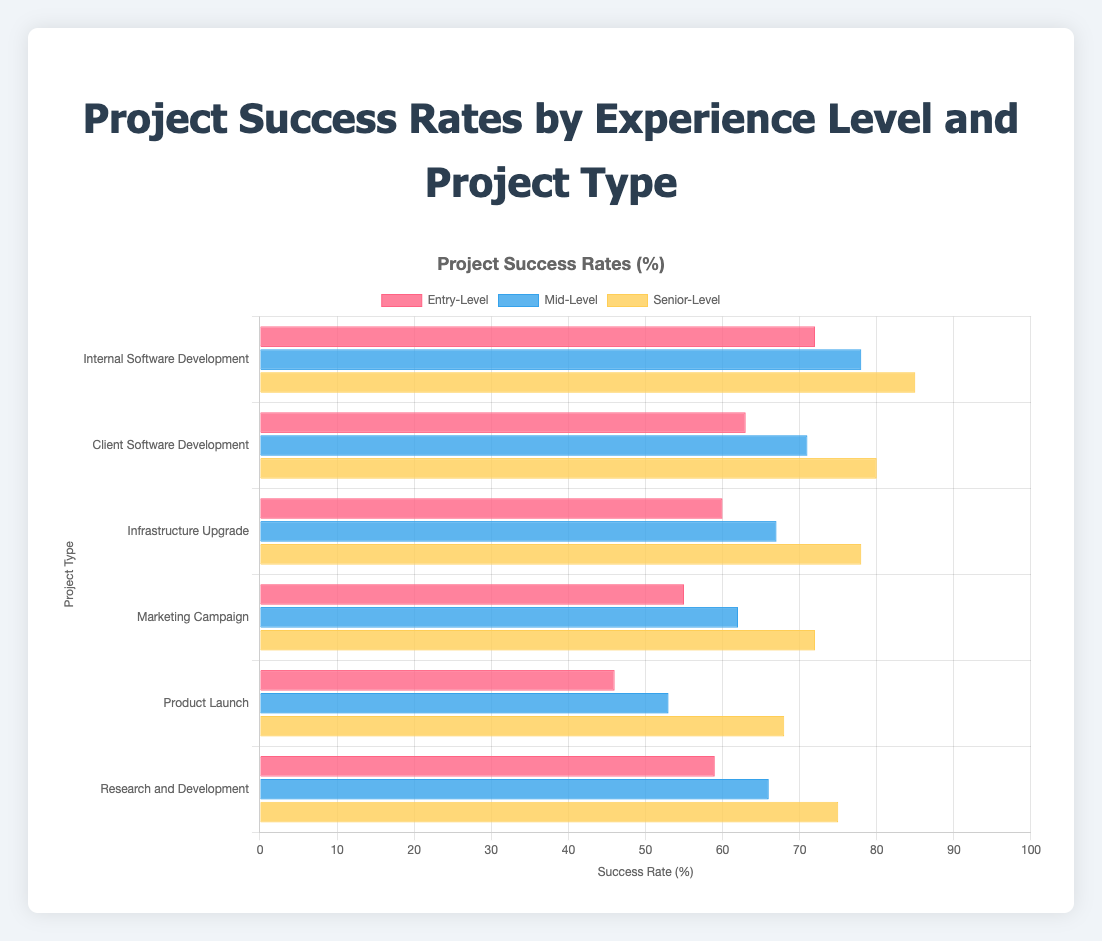What is the success rate difference between Entry-Level and Senior-Level project managers for Internal Software Development projects? The success rate for Entry-Level managers in Internal Software Development is 72%, and for Senior-Level managers, it is 85%. The difference is 85% - 72%.
Answer: 13% Which type of project has the highest success rate for Senior-Level project managers? Looking at the bars representing Senior-Level project managers, the highest success rate is found in Internal Software Development with a success rate of 85%.
Answer: Internal Software Development How much higher is the success rate for Mid-Level project managers in Marketing Campaign compared to Product Launch? The success rate for Mid-Level project managers in Marketing Campaign is 62%, and in Product Launch, it is 53%. The difference is 62% - 53%.
Answer: 9% Which experience level manages Research and Development projects with the lowest success rate? The success rates for Research and Development are 59% (Entry-Level), 66% (Mid-Level), and 75% (Senior-Level). The lowest is 59%.
Answer: Entry-Level What is the average success rate for Entry-Level project managers across all project types? The success rates for Entry-Level managers are 72%, 63%, 60%, 55%, 46%, and 59%. The average is (72 + 63 + 60 + 55 + 46 + 59) / 6.
Answer: 59.17% Which project type shows the most significant increase in success rate from Entry-Level to Senior-Level project managers? Calculate the differences for each project type: Internal Software Development (85 - 72 = 13), Client Software Development (80 - 63 = 17), Infrastructure Upgrade (78 - 60 = 18), Marketing Campaign (72 - 55 = 17), and Product Launch (68 - 46 = 22), Research and Development (75 - 59 = 16). The highest increase is in Product Launch.
Answer: Product Launch Are Mid-Level project managers more successful in Infrastructure Upgrade projects compared to Entry-Level managers in Client Software Development projects? The success rate for Mid-Level in Infrastructure Upgrade is 67%, and for Entry-Level in Client Software Development is 63%. 67% > 63%.
Answer: Yes What is the total success rate sum for Senior-Level project managers across all project types? Sum up the success rates for Senior-Level managers: 85 + 80 + 78 + 72 + 68 + 75.
Answer: 458 Which experience level has the smallest range in success rates across different project types? Range is calculated as the difference between the highest and lowest success rate within each experience level: Entry-Level (72 - 46 = 26), Mid-Level (78 - 53 = 25), Senior-Level (85 - 68 = 17). The smallest range is for Senior-Level.
Answer: Senior-Level 